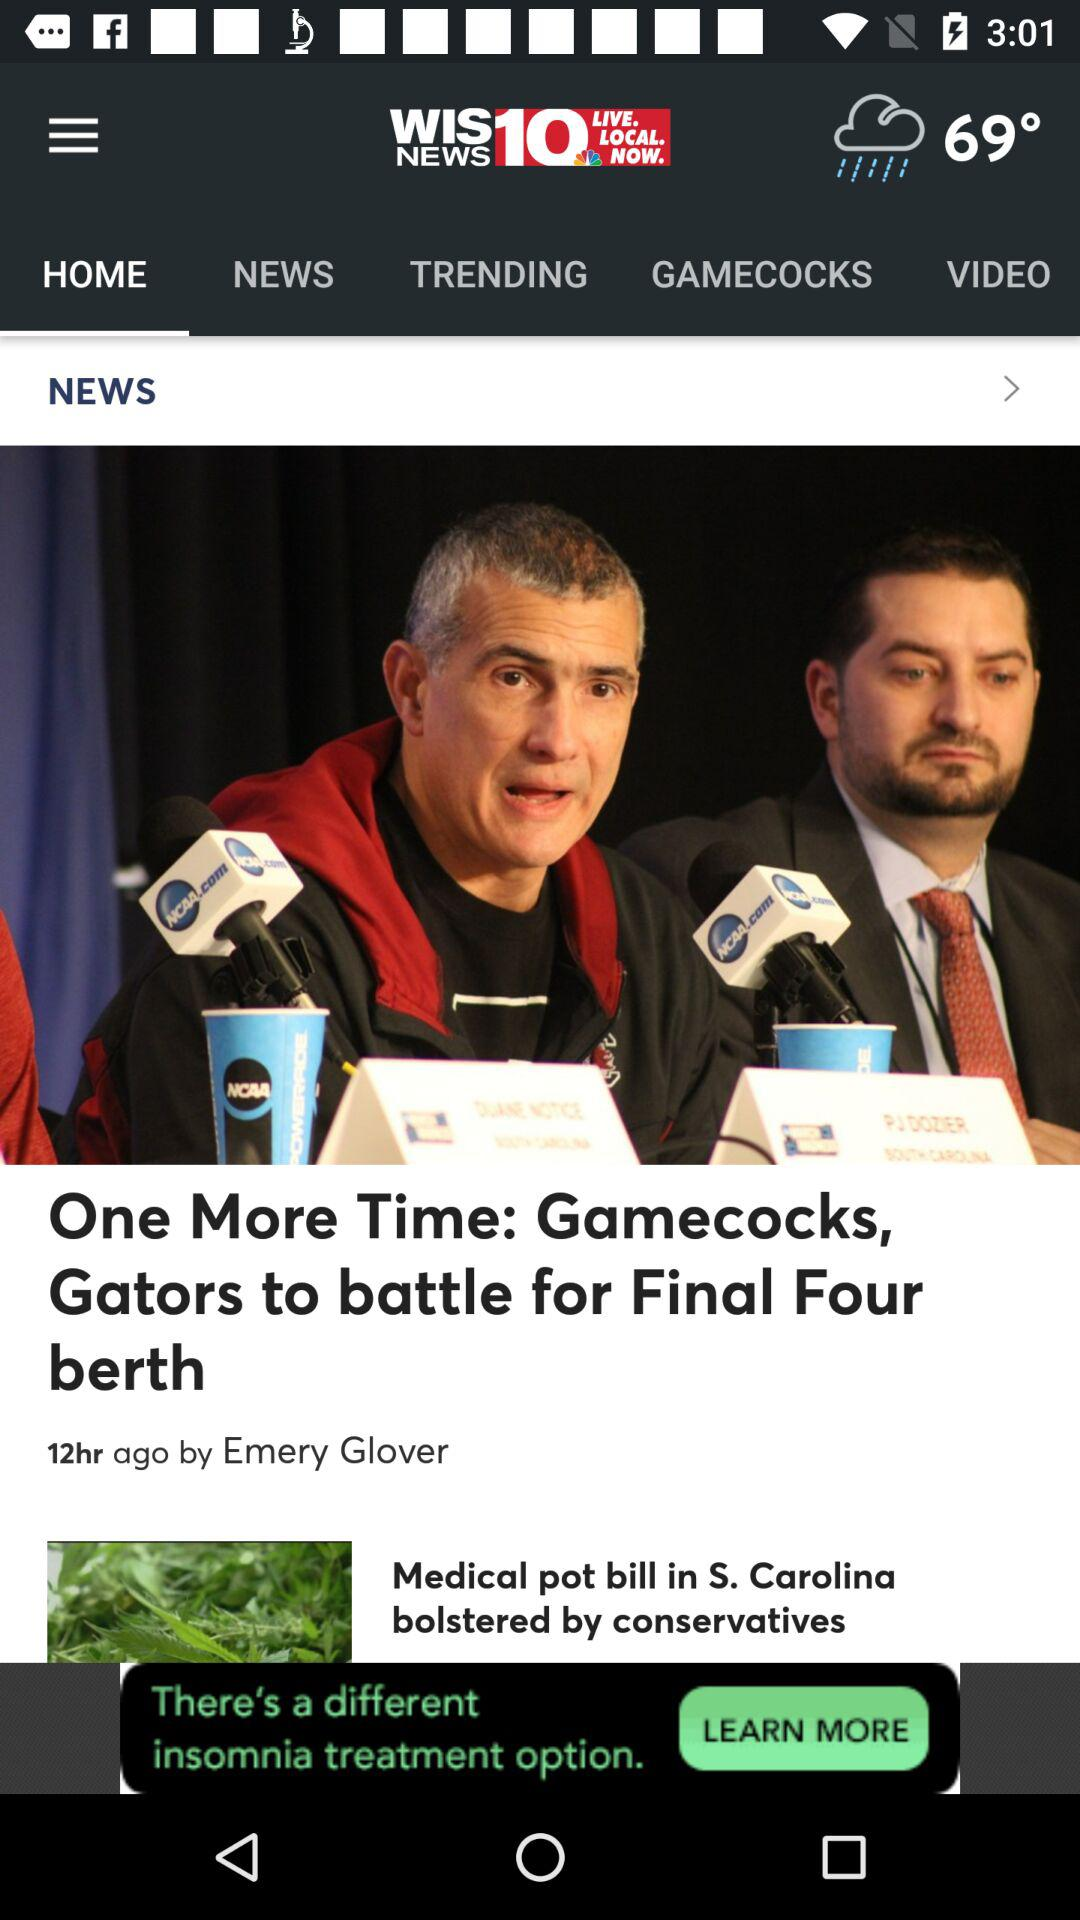How many hours ago was the article posted? The article was posted 12 hours ago. 